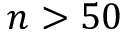Convert formula to latex. <formula><loc_0><loc_0><loc_500><loc_500>n > 5 0</formula> 